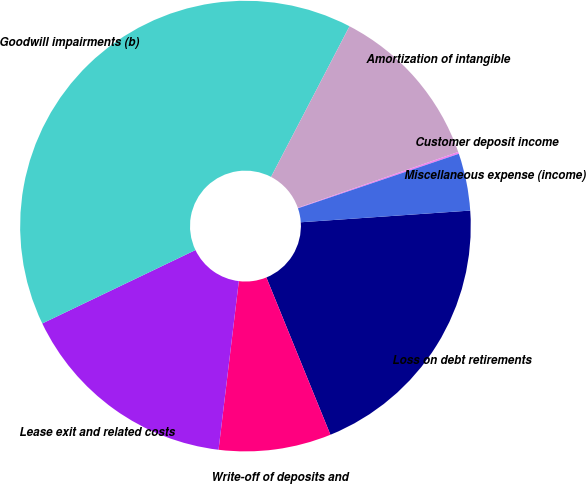Convert chart. <chart><loc_0><loc_0><loc_500><loc_500><pie_chart><fcel>Loss on debt retirements<fcel>Write-off of deposits and<fcel>Lease exit and related costs<fcel>Goodwill impairments (b)<fcel>Amortization of intangible<fcel>Customer deposit income<fcel>Miscellaneous expense (income)<nl><fcel>19.94%<fcel>8.06%<fcel>15.98%<fcel>39.75%<fcel>12.02%<fcel>0.14%<fcel>4.1%<nl></chart> 